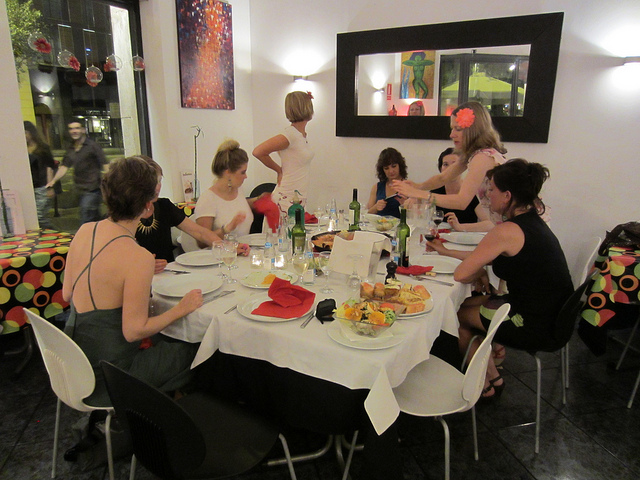<image>What are they eating? I don't know what exactly they are eating. It can be breakfast food, pizza, bread, sandwiches, fruit or dinner. What game is the family playing? I am not sure what game the family is playing. It could be charades or some other game. What are they eating? I don't know what they are eating. It could be breakfast, pizza, bread, sandwiches, fruit, or dinner. What game is the family playing? I don't know what game the family is playing. It can be seen 'charades', 'eating' or 'spin bottle'. 